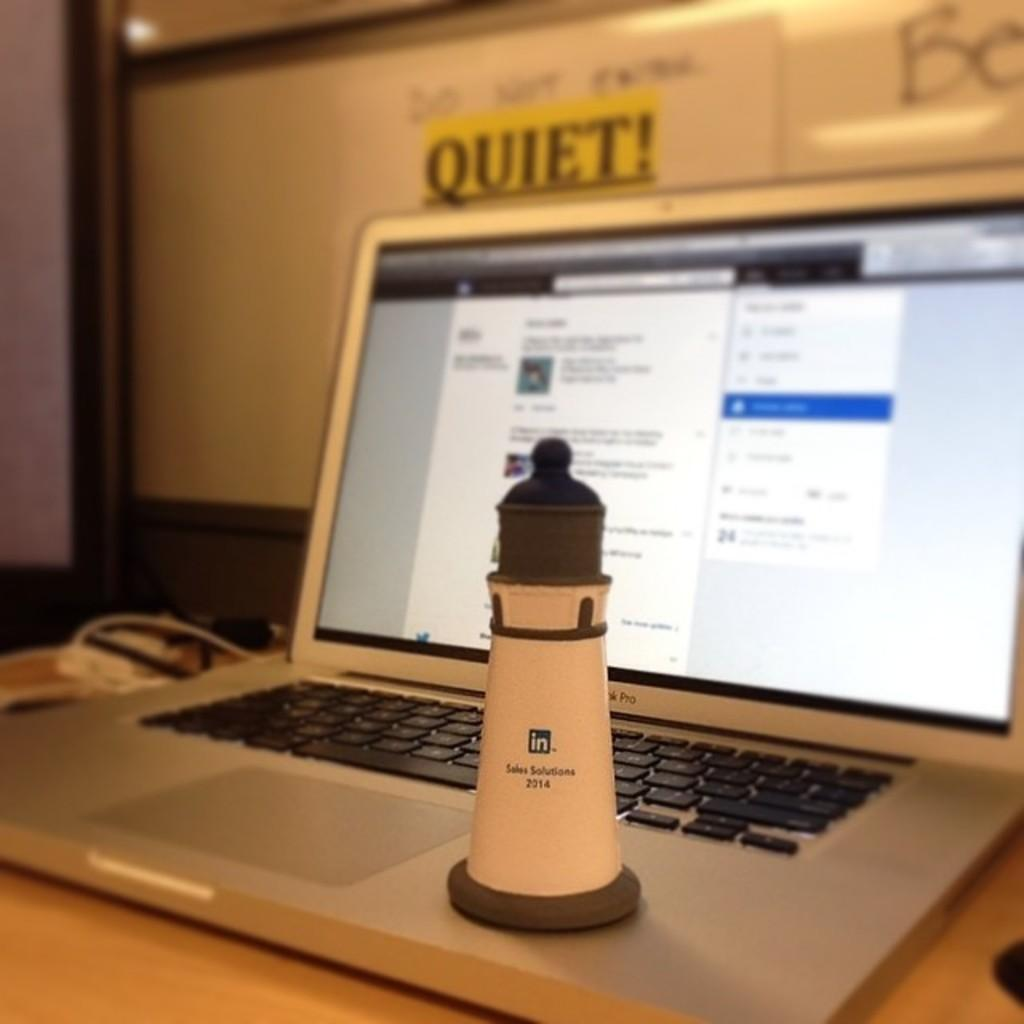<image>
Share a concise interpretation of the image provided. The sign above the laptop is warning everyone to be QUIET. 